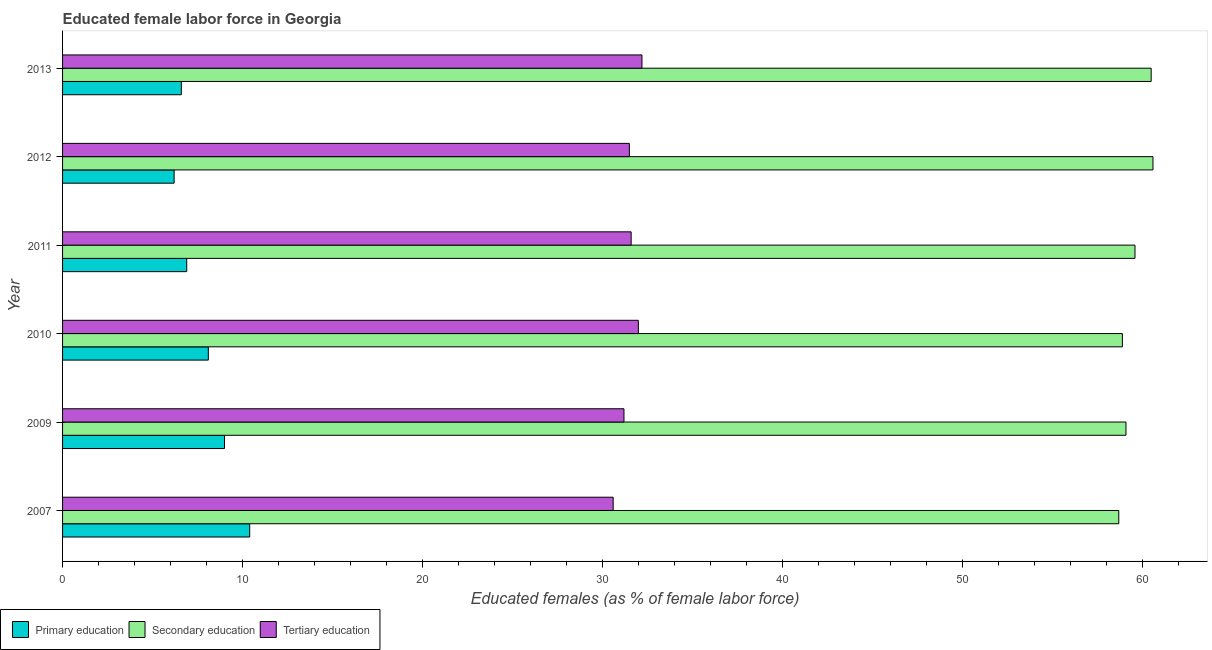How many different coloured bars are there?
Offer a very short reply. 3. Are the number of bars on each tick of the Y-axis equal?
Offer a terse response. Yes. What is the percentage of female labor force who received secondary education in 2007?
Provide a short and direct response. 58.7. Across all years, what is the maximum percentage of female labor force who received tertiary education?
Offer a terse response. 32.2. Across all years, what is the minimum percentage of female labor force who received primary education?
Your answer should be compact. 6.2. In which year was the percentage of female labor force who received primary education minimum?
Make the answer very short. 2012. What is the total percentage of female labor force who received primary education in the graph?
Your answer should be compact. 47.2. What is the difference between the percentage of female labor force who received tertiary education in 2007 and the percentage of female labor force who received primary education in 2010?
Give a very brief answer. 22.5. What is the average percentage of female labor force who received secondary education per year?
Provide a short and direct response. 59.57. In the year 2011, what is the difference between the percentage of female labor force who received secondary education and percentage of female labor force who received primary education?
Offer a terse response. 52.7. Is the percentage of female labor force who received tertiary education in 2007 less than that in 2013?
Your response must be concise. Yes. Is the difference between the percentage of female labor force who received primary education in 2009 and 2013 greater than the difference between the percentage of female labor force who received secondary education in 2009 and 2013?
Your answer should be compact. Yes. What is the difference between the highest and the lowest percentage of female labor force who received primary education?
Offer a very short reply. 4.2. What does the 2nd bar from the bottom in 2012 represents?
Offer a terse response. Secondary education. Is it the case that in every year, the sum of the percentage of female labor force who received primary education and percentage of female labor force who received secondary education is greater than the percentage of female labor force who received tertiary education?
Your answer should be compact. Yes. How many bars are there?
Offer a terse response. 18. What is the difference between two consecutive major ticks on the X-axis?
Offer a very short reply. 10. Does the graph contain grids?
Make the answer very short. No. Where does the legend appear in the graph?
Keep it short and to the point. Bottom left. How are the legend labels stacked?
Provide a succinct answer. Horizontal. What is the title of the graph?
Make the answer very short. Educated female labor force in Georgia. Does "Social Protection and Labor" appear as one of the legend labels in the graph?
Give a very brief answer. No. What is the label or title of the X-axis?
Provide a short and direct response. Educated females (as % of female labor force). What is the label or title of the Y-axis?
Keep it short and to the point. Year. What is the Educated females (as % of female labor force) in Primary education in 2007?
Offer a terse response. 10.4. What is the Educated females (as % of female labor force) in Secondary education in 2007?
Give a very brief answer. 58.7. What is the Educated females (as % of female labor force) of Tertiary education in 2007?
Your response must be concise. 30.6. What is the Educated females (as % of female labor force) in Primary education in 2009?
Ensure brevity in your answer.  9. What is the Educated females (as % of female labor force) in Secondary education in 2009?
Offer a terse response. 59.1. What is the Educated females (as % of female labor force) in Tertiary education in 2009?
Give a very brief answer. 31.2. What is the Educated females (as % of female labor force) of Primary education in 2010?
Offer a very short reply. 8.1. What is the Educated females (as % of female labor force) of Secondary education in 2010?
Give a very brief answer. 58.9. What is the Educated females (as % of female labor force) of Primary education in 2011?
Your answer should be compact. 6.9. What is the Educated females (as % of female labor force) of Secondary education in 2011?
Your answer should be very brief. 59.6. What is the Educated females (as % of female labor force) in Tertiary education in 2011?
Give a very brief answer. 31.6. What is the Educated females (as % of female labor force) in Primary education in 2012?
Provide a succinct answer. 6.2. What is the Educated females (as % of female labor force) of Secondary education in 2012?
Make the answer very short. 60.6. What is the Educated females (as % of female labor force) of Tertiary education in 2012?
Provide a short and direct response. 31.5. What is the Educated females (as % of female labor force) of Primary education in 2013?
Your answer should be very brief. 6.6. What is the Educated females (as % of female labor force) of Secondary education in 2013?
Offer a very short reply. 60.5. What is the Educated females (as % of female labor force) of Tertiary education in 2013?
Your answer should be compact. 32.2. Across all years, what is the maximum Educated females (as % of female labor force) in Primary education?
Provide a short and direct response. 10.4. Across all years, what is the maximum Educated females (as % of female labor force) of Secondary education?
Your response must be concise. 60.6. Across all years, what is the maximum Educated females (as % of female labor force) in Tertiary education?
Your response must be concise. 32.2. Across all years, what is the minimum Educated females (as % of female labor force) in Primary education?
Your answer should be very brief. 6.2. Across all years, what is the minimum Educated females (as % of female labor force) in Secondary education?
Make the answer very short. 58.7. Across all years, what is the minimum Educated females (as % of female labor force) in Tertiary education?
Your answer should be compact. 30.6. What is the total Educated females (as % of female labor force) in Primary education in the graph?
Your answer should be compact. 47.2. What is the total Educated females (as % of female labor force) in Secondary education in the graph?
Provide a short and direct response. 357.4. What is the total Educated females (as % of female labor force) in Tertiary education in the graph?
Offer a very short reply. 189.1. What is the difference between the Educated females (as % of female labor force) of Secondary education in 2007 and that in 2009?
Provide a succinct answer. -0.4. What is the difference between the Educated females (as % of female labor force) of Tertiary education in 2007 and that in 2009?
Give a very brief answer. -0.6. What is the difference between the Educated females (as % of female labor force) of Primary education in 2007 and that in 2010?
Keep it short and to the point. 2.3. What is the difference between the Educated females (as % of female labor force) in Secondary education in 2007 and that in 2010?
Keep it short and to the point. -0.2. What is the difference between the Educated females (as % of female labor force) in Tertiary education in 2007 and that in 2010?
Your answer should be compact. -1.4. What is the difference between the Educated females (as % of female labor force) of Primary education in 2007 and that in 2011?
Your answer should be very brief. 3.5. What is the difference between the Educated females (as % of female labor force) of Primary education in 2007 and that in 2012?
Ensure brevity in your answer.  4.2. What is the difference between the Educated females (as % of female labor force) in Primary education in 2007 and that in 2013?
Your response must be concise. 3.8. What is the difference between the Educated females (as % of female labor force) of Secondary education in 2007 and that in 2013?
Ensure brevity in your answer.  -1.8. What is the difference between the Educated females (as % of female labor force) of Primary education in 2009 and that in 2010?
Your answer should be compact. 0.9. What is the difference between the Educated females (as % of female labor force) in Secondary education in 2009 and that in 2010?
Provide a succinct answer. 0.2. What is the difference between the Educated females (as % of female labor force) in Primary education in 2009 and that in 2011?
Give a very brief answer. 2.1. What is the difference between the Educated females (as % of female labor force) of Secondary education in 2009 and that in 2011?
Provide a short and direct response. -0.5. What is the difference between the Educated females (as % of female labor force) in Secondary education in 2009 and that in 2012?
Offer a very short reply. -1.5. What is the difference between the Educated females (as % of female labor force) of Primary education in 2009 and that in 2013?
Your answer should be very brief. 2.4. What is the difference between the Educated females (as % of female labor force) of Tertiary education in 2009 and that in 2013?
Ensure brevity in your answer.  -1. What is the difference between the Educated females (as % of female labor force) of Tertiary education in 2010 and that in 2011?
Provide a succinct answer. 0.4. What is the difference between the Educated females (as % of female labor force) in Primary education in 2010 and that in 2013?
Your answer should be very brief. 1.5. What is the difference between the Educated females (as % of female labor force) in Secondary education in 2010 and that in 2013?
Your response must be concise. -1.6. What is the difference between the Educated females (as % of female labor force) in Tertiary education in 2010 and that in 2013?
Your answer should be compact. -0.2. What is the difference between the Educated females (as % of female labor force) of Primary education in 2011 and that in 2012?
Make the answer very short. 0.7. What is the difference between the Educated females (as % of female labor force) of Secondary education in 2011 and that in 2012?
Offer a very short reply. -1. What is the difference between the Educated females (as % of female labor force) in Primary education in 2011 and that in 2013?
Keep it short and to the point. 0.3. What is the difference between the Educated females (as % of female labor force) of Tertiary education in 2011 and that in 2013?
Your response must be concise. -0.6. What is the difference between the Educated females (as % of female labor force) of Primary education in 2007 and the Educated females (as % of female labor force) of Secondary education in 2009?
Give a very brief answer. -48.7. What is the difference between the Educated females (as % of female labor force) of Primary education in 2007 and the Educated females (as % of female labor force) of Tertiary education in 2009?
Your answer should be very brief. -20.8. What is the difference between the Educated females (as % of female labor force) in Secondary education in 2007 and the Educated females (as % of female labor force) in Tertiary education in 2009?
Provide a succinct answer. 27.5. What is the difference between the Educated females (as % of female labor force) in Primary education in 2007 and the Educated females (as % of female labor force) in Secondary education in 2010?
Ensure brevity in your answer.  -48.5. What is the difference between the Educated females (as % of female labor force) in Primary education in 2007 and the Educated females (as % of female labor force) in Tertiary education in 2010?
Provide a short and direct response. -21.6. What is the difference between the Educated females (as % of female labor force) of Secondary education in 2007 and the Educated females (as % of female labor force) of Tertiary education in 2010?
Your answer should be very brief. 26.7. What is the difference between the Educated females (as % of female labor force) in Primary education in 2007 and the Educated females (as % of female labor force) in Secondary education in 2011?
Ensure brevity in your answer.  -49.2. What is the difference between the Educated females (as % of female labor force) of Primary education in 2007 and the Educated females (as % of female labor force) of Tertiary education in 2011?
Provide a succinct answer. -21.2. What is the difference between the Educated females (as % of female labor force) of Secondary education in 2007 and the Educated females (as % of female labor force) of Tertiary education in 2011?
Give a very brief answer. 27.1. What is the difference between the Educated females (as % of female labor force) in Primary education in 2007 and the Educated females (as % of female labor force) in Secondary education in 2012?
Offer a very short reply. -50.2. What is the difference between the Educated females (as % of female labor force) in Primary education in 2007 and the Educated females (as % of female labor force) in Tertiary education in 2012?
Provide a succinct answer. -21.1. What is the difference between the Educated females (as % of female labor force) of Secondary education in 2007 and the Educated females (as % of female labor force) of Tertiary education in 2012?
Your answer should be very brief. 27.2. What is the difference between the Educated females (as % of female labor force) of Primary education in 2007 and the Educated females (as % of female labor force) of Secondary education in 2013?
Offer a very short reply. -50.1. What is the difference between the Educated females (as % of female labor force) of Primary education in 2007 and the Educated females (as % of female labor force) of Tertiary education in 2013?
Make the answer very short. -21.8. What is the difference between the Educated females (as % of female labor force) of Primary education in 2009 and the Educated females (as % of female labor force) of Secondary education in 2010?
Provide a short and direct response. -49.9. What is the difference between the Educated females (as % of female labor force) in Primary education in 2009 and the Educated females (as % of female labor force) in Tertiary education in 2010?
Provide a succinct answer. -23. What is the difference between the Educated females (as % of female labor force) of Secondary education in 2009 and the Educated females (as % of female labor force) of Tertiary education in 2010?
Provide a succinct answer. 27.1. What is the difference between the Educated females (as % of female labor force) in Primary education in 2009 and the Educated females (as % of female labor force) in Secondary education in 2011?
Provide a succinct answer. -50.6. What is the difference between the Educated females (as % of female labor force) in Primary education in 2009 and the Educated females (as % of female labor force) in Tertiary education in 2011?
Ensure brevity in your answer.  -22.6. What is the difference between the Educated females (as % of female labor force) of Secondary education in 2009 and the Educated females (as % of female labor force) of Tertiary education in 2011?
Your answer should be compact. 27.5. What is the difference between the Educated females (as % of female labor force) of Primary education in 2009 and the Educated females (as % of female labor force) of Secondary education in 2012?
Give a very brief answer. -51.6. What is the difference between the Educated females (as % of female labor force) in Primary education in 2009 and the Educated females (as % of female labor force) in Tertiary education in 2012?
Give a very brief answer. -22.5. What is the difference between the Educated females (as % of female labor force) of Secondary education in 2009 and the Educated females (as % of female labor force) of Tertiary education in 2012?
Your answer should be very brief. 27.6. What is the difference between the Educated females (as % of female labor force) in Primary education in 2009 and the Educated females (as % of female labor force) in Secondary education in 2013?
Ensure brevity in your answer.  -51.5. What is the difference between the Educated females (as % of female labor force) in Primary education in 2009 and the Educated females (as % of female labor force) in Tertiary education in 2013?
Your response must be concise. -23.2. What is the difference between the Educated females (as % of female labor force) in Secondary education in 2009 and the Educated females (as % of female labor force) in Tertiary education in 2013?
Give a very brief answer. 26.9. What is the difference between the Educated females (as % of female labor force) of Primary education in 2010 and the Educated females (as % of female labor force) of Secondary education in 2011?
Give a very brief answer. -51.5. What is the difference between the Educated females (as % of female labor force) in Primary education in 2010 and the Educated females (as % of female labor force) in Tertiary education in 2011?
Your response must be concise. -23.5. What is the difference between the Educated females (as % of female labor force) of Secondary education in 2010 and the Educated females (as % of female labor force) of Tertiary education in 2011?
Give a very brief answer. 27.3. What is the difference between the Educated females (as % of female labor force) in Primary education in 2010 and the Educated females (as % of female labor force) in Secondary education in 2012?
Offer a very short reply. -52.5. What is the difference between the Educated females (as % of female labor force) of Primary education in 2010 and the Educated females (as % of female labor force) of Tertiary education in 2012?
Provide a succinct answer. -23.4. What is the difference between the Educated females (as % of female labor force) in Secondary education in 2010 and the Educated females (as % of female labor force) in Tertiary education in 2012?
Keep it short and to the point. 27.4. What is the difference between the Educated females (as % of female labor force) in Primary education in 2010 and the Educated females (as % of female labor force) in Secondary education in 2013?
Keep it short and to the point. -52.4. What is the difference between the Educated females (as % of female labor force) of Primary education in 2010 and the Educated females (as % of female labor force) of Tertiary education in 2013?
Your response must be concise. -24.1. What is the difference between the Educated females (as % of female labor force) in Secondary education in 2010 and the Educated females (as % of female labor force) in Tertiary education in 2013?
Offer a terse response. 26.7. What is the difference between the Educated females (as % of female labor force) of Primary education in 2011 and the Educated females (as % of female labor force) of Secondary education in 2012?
Your response must be concise. -53.7. What is the difference between the Educated females (as % of female labor force) in Primary education in 2011 and the Educated females (as % of female labor force) in Tertiary education in 2012?
Give a very brief answer. -24.6. What is the difference between the Educated females (as % of female labor force) in Secondary education in 2011 and the Educated females (as % of female labor force) in Tertiary education in 2012?
Provide a succinct answer. 28.1. What is the difference between the Educated females (as % of female labor force) of Primary education in 2011 and the Educated females (as % of female labor force) of Secondary education in 2013?
Make the answer very short. -53.6. What is the difference between the Educated females (as % of female labor force) in Primary education in 2011 and the Educated females (as % of female labor force) in Tertiary education in 2013?
Your answer should be compact. -25.3. What is the difference between the Educated females (as % of female labor force) in Secondary education in 2011 and the Educated females (as % of female labor force) in Tertiary education in 2013?
Offer a terse response. 27.4. What is the difference between the Educated females (as % of female labor force) of Primary education in 2012 and the Educated females (as % of female labor force) of Secondary education in 2013?
Keep it short and to the point. -54.3. What is the difference between the Educated females (as % of female labor force) of Primary education in 2012 and the Educated females (as % of female labor force) of Tertiary education in 2013?
Your answer should be compact. -26. What is the difference between the Educated females (as % of female labor force) in Secondary education in 2012 and the Educated females (as % of female labor force) in Tertiary education in 2013?
Offer a terse response. 28.4. What is the average Educated females (as % of female labor force) of Primary education per year?
Offer a terse response. 7.87. What is the average Educated females (as % of female labor force) of Secondary education per year?
Your answer should be compact. 59.57. What is the average Educated females (as % of female labor force) in Tertiary education per year?
Provide a short and direct response. 31.52. In the year 2007, what is the difference between the Educated females (as % of female labor force) of Primary education and Educated females (as % of female labor force) of Secondary education?
Give a very brief answer. -48.3. In the year 2007, what is the difference between the Educated females (as % of female labor force) in Primary education and Educated females (as % of female labor force) in Tertiary education?
Offer a very short reply. -20.2. In the year 2007, what is the difference between the Educated females (as % of female labor force) in Secondary education and Educated females (as % of female labor force) in Tertiary education?
Your answer should be very brief. 28.1. In the year 2009, what is the difference between the Educated females (as % of female labor force) in Primary education and Educated females (as % of female labor force) in Secondary education?
Give a very brief answer. -50.1. In the year 2009, what is the difference between the Educated females (as % of female labor force) in Primary education and Educated females (as % of female labor force) in Tertiary education?
Your answer should be compact. -22.2. In the year 2009, what is the difference between the Educated females (as % of female labor force) of Secondary education and Educated females (as % of female labor force) of Tertiary education?
Make the answer very short. 27.9. In the year 2010, what is the difference between the Educated females (as % of female labor force) in Primary education and Educated females (as % of female labor force) in Secondary education?
Provide a succinct answer. -50.8. In the year 2010, what is the difference between the Educated females (as % of female labor force) in Primary education and Educated females (as % of female labor force) in Tertiary education?
Keep it short and to the point. -23.9. In the year 2010, what is the difference between the Educated females (as % of female labor force) of Secondary education and Educated females (as % of female labor force) of Tertiary education?
Your answer should be compact. 26.9. In the year 2011, what is the difference between the Educated females (as % of female labor force) in Primary education and Educated females (as % of female labor force) in Secondary education?
Make the answer very short. -52.7. In the year 2011, what is the difference between the Educated females (as % of female labor force) of Primary education and Educated females (as % of female labor force) of Tertiary education?
Make the answer very short. -24.7. In the year 2011, what is the difference between the Educated females (as % of female labor force) of Secondary education and Educated females (as % of female labor force) of Tertiary education?
Offer a terse response. 28. In the year 2012, what is the difference between the Educated females (as % of female labor force) in Primary education and Educated females (as % of female labor force) in Secondary education?
Provide a succinct answer. -54.4. In the year 2012, what is the difference between the Educated females (as % of female labor force) in Primary education and Educated females (as % of female labor force) in Tertiary education?
Provide a succinct answer. -25.3. In the year 2012, what is the difference between the Educated females (as % of female labor force) of Secondary education and Educated females (as % of female labor force) of Tertiary education?
Make the answer very short. 29.1. In the year 2013, what is the difference between the Educated females (as % of female labor force) in Primary education and Educated females (as % of female labor force) in Secondary education?
Give a very brief answer. -53.9. In the year 2013, what is the difference between the Educated females (as % of female labor force) in Primary education and Educated females (as % of female labor force) in Tertiary education?
Offer a very short reply. -25.6. In the year 2013, what is the difference between the Educated females (as % of female labor force) of Secondary education and Educated females (as % of female labor force) of Tertiary education?
Offer a very short reply. 28.3. What is the ratio of the Educated females (as % of female labor force) in Primary education in 2007 to that in 2009?
Make the answer very short. 1.16. What is the ratio of the Educated females (as % of female labor force) of Secondary education in 2007 to that in 2009?
Ensure brevity in your answer.  0.99. What is the ratio of the Educated females (as % of female labor force) in Tertiary education in 2007 to that in 2009?
Your response must be concise. 0.98. What is the ratio of the Educated females (as % of female labor force) of Primary education in 2007 to that in 2010?
Offer a very short reply. 1.28. What is the ratio of the Educated females (as % of female labor force) in Secondary education in 2007 to that in 2010?
Provide a short and direct response. 1. What is the ratio of the Educated females (as % of female labor force) of Tertiary education in 2007 to that in 2010?
Provide a short and direct response. 0.96. What is the ratio of the Educated females (as % of female labor force) in Primary education in 2007 to that in 2011?
Keep it short and to the point. 1.51. What is the ratio of the Educated females (as % of female labor force) in Secondary education in 2007 to that in 2011?
Provide a short and direct response. 0.98. What is the ratio of the Educated females (as % of female labor force) of Tertiary education in 2007 to that in 2011?
Offer a very short reply. 0.97. What is the ratio of the Educated females (as % of female labor force) in Primary education in 2007 to that in 2012?
Ensure brevity in your answer.  1.68. What is the ratio of the Educated females (as % of female labor force) of Secondary education in 2007 to that in 2012?
Offer a very short reply. 0.97. What is the ratio of the Educated females (as % of female labor force) of Tertiary education in 2007 to that in 2012?
Offer a terse response. 0.97. What is the ratio of the Educated females (as % of female labor force) of Primary education in 2007 to that in 2013?
Give a very brief answer. 1.58. What is the ratio of the Educated females (as % of female labor force) of Secondary education in 2007 to that in 2013?
Offer a terse response. 0.97. What is the ratio of the Educated females (as % of female labor force) in Tertiary education in 2007 to that in 2013?
Offer a terse response. 0.95. What is the ratio of the Educated females (as % of female labor force) of Primary education in 2009 to that in 2010?
Your answer should be very brief. 1.11. What is the ratio of the Educated females (as % of female labor force) of Tertiary education in 2009 to that in 2010?
Provide a short and direct response. 0.97. What is the ratio of the Educated females (as % of female labor force) in Primary education in 2009 to that in 2011?
Keep it short and to the point. 1.3. What is the ratio of the Educated females (as % of female labor force) in Secondary education in 2009 to that in 2011?
Provide a succinct answer. 0.99. What is the ratio of the Educated females (as % of female labor force) of Tertiary education in 2009 to that in 2011?
Your response must be concise. 0.99. What is the ratio of the Educated females (as % of female labor force) in Primary education in 2009 to that in 2012?
Make the answer very short. 1.45. What is the ratio of the Educated females (as % of female labor force) of Secondary education in 2009 to that in 2012?
Make the answer very short. 0.98. What is the ratio of the Educated females (as % of female labor force) in Primary education in 2009 to that in 2013?
Give a very brief answer. 1.36. What is the ratio of the Educated females (as % of female labor force) in Secondary education in 2009 to that in 2013?
Your answer should be compact. 0.98. What is the ratio of the Educated females (as % of female labor force) of Tertiary education in 2009 to that in 2013?
Your answer should be very brief. 0.97. What is the ratio of the Educated females (as % of female labor force) in Primary education in 2010 to that in 2011?
Offer a terse response. 1.17. What is the ratio of the Educated females (as % of female labor force) in Secondary education in 2010 to that in 2011?
Keep it short and to the point. 0.99. What is the ratio of the Educated females (as % of female labor force) of Tertiary education in 2010 to that in 2011?
Keep it short and to the point. 1.01. What is the ratio of the Educated females (as % of female labor force) in Primary education in 2010 to that in 2012?
Keep it short and to the point. 1.31. What is the ratio of the Educated females (as % of female labor force) of Secondary education in 2010 to that in 2012?
Provide a succinct answer. 0.97. What is the ratio of the Educated females (as % of female labor force) of Tertiary education in 2010 to that in 2012?
Ensure brevity in your answer.  1.02. What is the ratio of the Educated females (as % of female labor force) in Primary education in 2010 to that in 2013?
Offer a very short reply. 1.23. What is the ratio of the Educated females (as % of female labor force) of Secondary education in 2010 to that in 2013?
Your answer should be compact. 0.97. What is the ratio of the Educated females (as % of female labor force) in Primary education in 2011 to that in 2012?
Ensure brevity in your answer.  1.11. What is the ratio of the Educated females (as % of female labor force) of Secondary education in 2011 to that in 2012?
Provide a succinct answer. 0.98. What is the ratio of the Educated females (as % of female labor force) in Primary education in 2011 to that in 2013?
Your response must be concise. 1.05. What is the ratio of the Educated females (as % of female labor force) in Secondary education in 2011 to that in 2013?
Provide a short and direct response. 0.99. What is the ratio of the Educated females (as % of female labor force) of Tertiary education in 2011 to that in 2013?
Offer a very short reply. 0.98. What is the ratio of the Educated females (as % of female labor force) in Primary education in 2012 to that in 2013?
Give a very brief answer. 0.94. What is the ratio of the Educated females (as % of female labor force) of Secondary education in 2012 to that in 2013?
Ensure brevity in your answer.  1. What is the ratio of the Educated females (as % of female labor force) of Tertiary education in 2012 to that in 2013?
Offer a very short reply. 0.98. What is the difference between the highest and the second highest Educated females (as % of female labor force) in Primary education?
Ensure brevity in your answer.  1.4. What is the difference between the highest and the second highest Educated females (as % of female labor force) of Secondary education?
Make the answer very short. 0.1. What is the difference between the highest and the second highest Educated females (as % of female labor force) in Tertiary education?
Your answer should be compact. 0.2. What is the difference between the highest and the lowest Educated females (as % of female labor force) of Primary education?
Offer a very short reply. 4.2. 